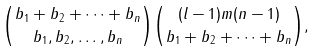Convert formula to latex. <formula><loc_0><loc_0><loc_500><loc_500>\binom { b _ { 1 } + b _ { 2 } + \dots + b _ { n } } { b _ { 1 } , b _ { 2 } , \dots , b _ { n } } \binom { ( l - 1 ) m ( n - 1 ) } { b _ { 1 } + b _ { 2 } + \dots + b _ { n } } ,</formula> 